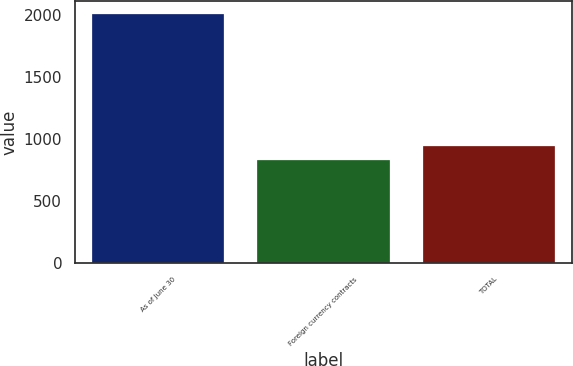<chart> <loc_0><loc_0><loc_500><loc_500><bar_chart><fcel>As of June 30<fcel>Foreign currency contracts<fcel>TOTAL<nl><fcel>2012<fcel>831<fcel>949.1<nl></chart> 